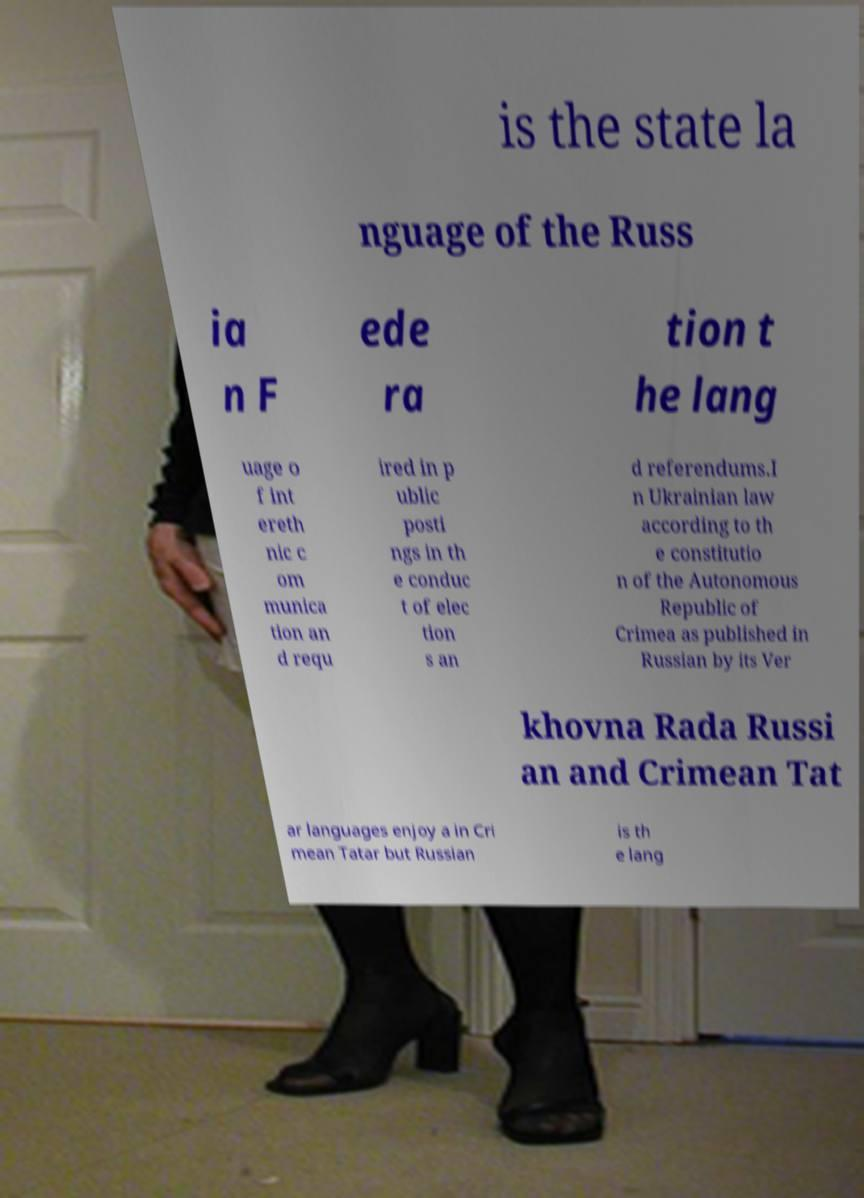Could you extract and type out the text from this image? is the state la nguage of the Russ ia n F ede ra tion t he lang uage o f int ereth nic c om munica tion an d requ ired in p ublic posti ngs in th e conduc t of elec tion s an d referendums.I n Ukrainian law according to th e constitutio n of the Autonomous Republic of Crimea as published in Russian by its Ver khovna Rada Russi an and Crimean Tat ar languages enjoy a in Cri mean Tatar but Russian is th e lang 